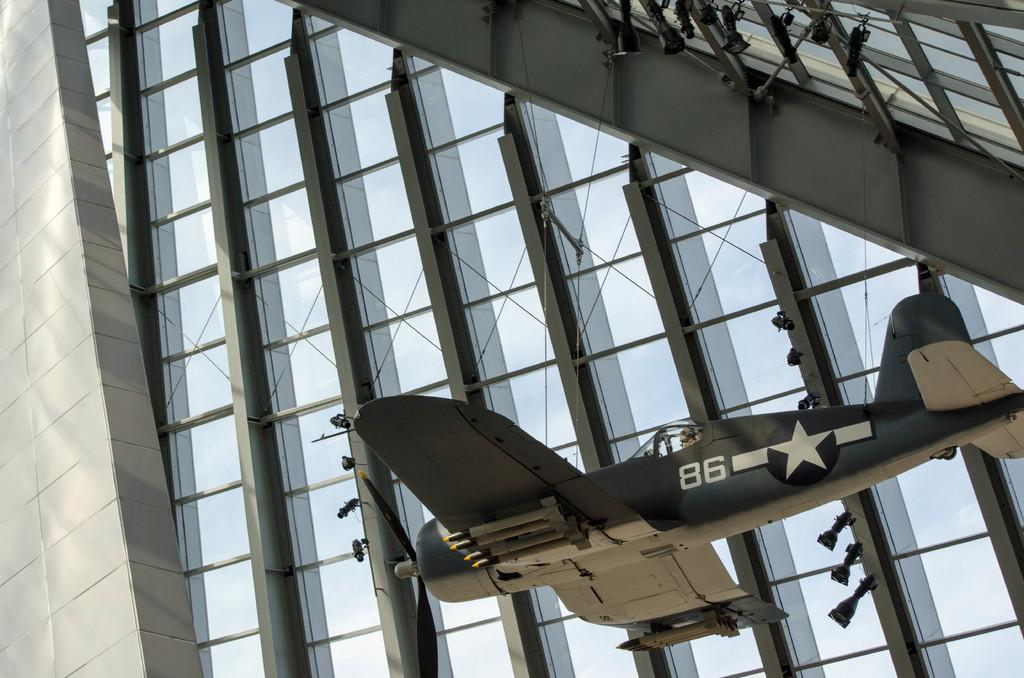What is the main structure in the image? There is a huge building in the image. What material are the pillars of the building made of? The building has iron pillars. What other object can be seen in the image besides the building? There is an aircraft in the image. How is the aircraft secured in the image? The aircraft is tied with wires. What type of blood is visible on the aircraft in the image? There is no blood visible on the aircraft in the image. Can you see a boat in the image? There is no boat present in the image. 